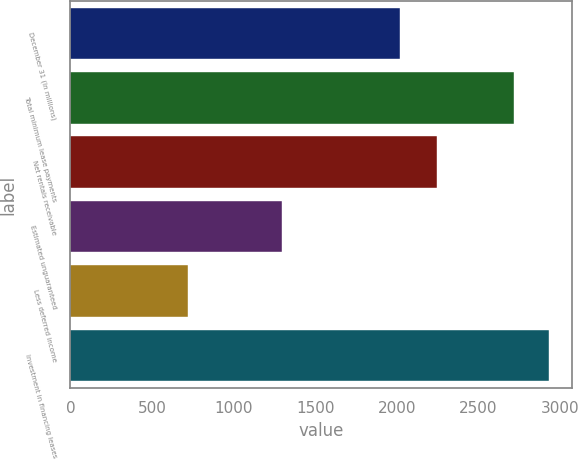Convert chart to OTSL. <chart><loc_0><loc_0><loc_500><loc_500><bar_chart><fcel>December 31 (In millions)<fcel>Total minimum lease payments<fcel>Net rentals receivable<fcel>Estimated unguaranteed<fcel>Less deferred income<fcel>Investment in financing leases<nl><fcel>2018<fcel>2719<fcel>2245<fcel>1295<fcel>718<fcel>2929.4<nl></chart> 